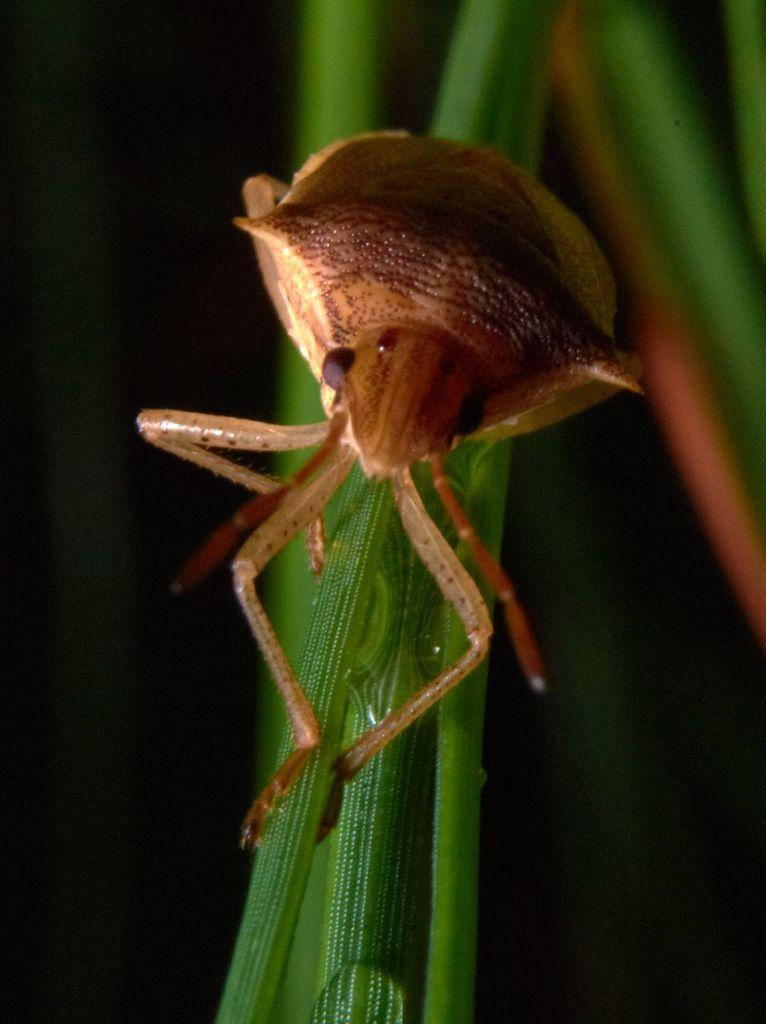What is present on the leaf in the image? There is an insect on the leaf in the image. Can you describe the insect's location in the image? The insect is on a leaf in the image. What can be observed about the background of the image? The background of the image is blurry. What type of shoes can be seen in the image? There are no shoes present in the image; it features an insect on a leaf with a blurry background. 